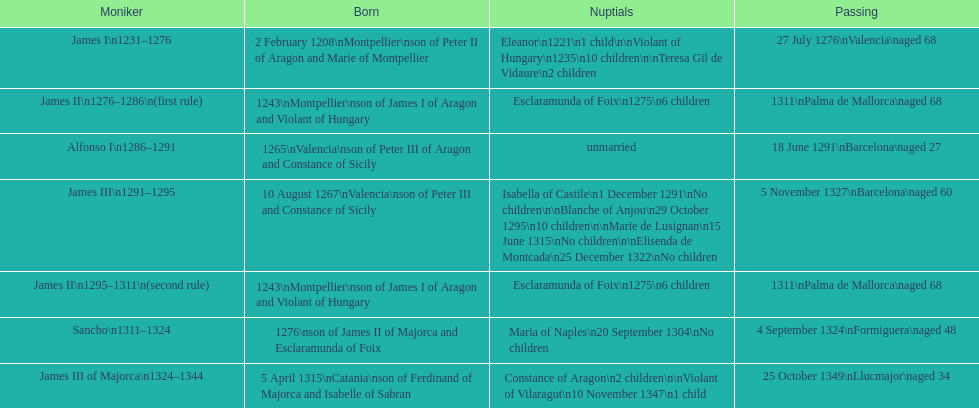How many of these monarchs died before the age of 65? 4. 